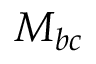Convert formula to latex. <formula><loc_0><loc_0><loc_500><loc_500>M _ { b c }</formula> 